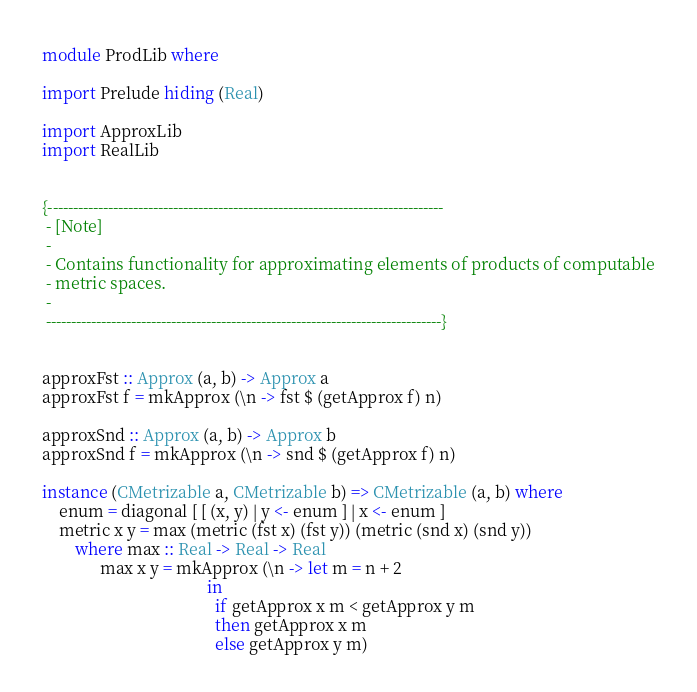Convert code to text. <code><loc_0><loc_0><loc_500><loc_500><_Haskell_>module ProdLib where

import Prelude hiding (Real)

import ApproxLib
import RealLib


{-------------------------------------------------------------------------------
 - [Note]
 -
 - Contains functionality for approximating elements of products of computable
 - metric spaces.
 -
 -------------------------------------------------------------------------------}


approxFst :: Approx (a, b) -> Approx a
approxFst f = mkApprox (\n -> fst $ (getApprox f) n)

approxSnd :: Approx (a, b) -> Approx b
approxSnd f = mkApprox (\n -> snd $ (getApprox f) n)

instance (CMetrizable a, CMetrizable b) => CMetrizable (a, b) where
    enum = diagonal [ [ (x, y) | y <- enum ] | x <- enum ]
    metric x y = max (metric (fst x) (fst y)) (metric (snd x) (snd y))
        where max :: Real -> Real -> Real
              max x y = mkApprox (\n -> let m = n + 2
                                        in
                                          if getApprox x m < getApprox y m
                                          then getApprox x m
                                          else getApprox y m)
</code> 